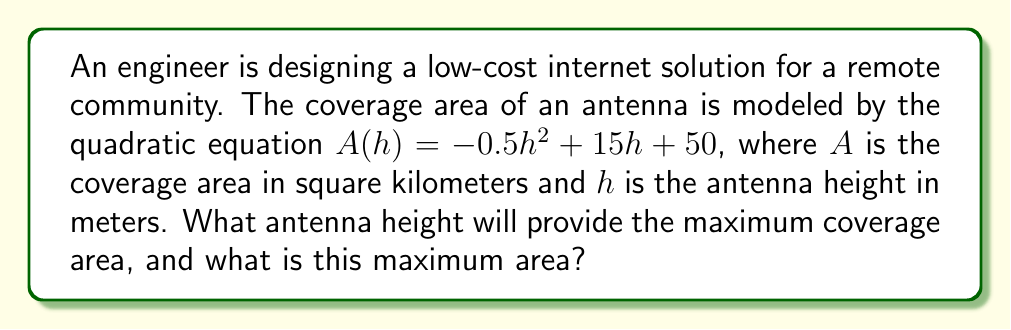Could you help me with this problem? To solve this problem, we'll follow these steps:

1) The coverage area is given by a quadratic function $A(h) = -0.5h^2 + 15h + 50$. The maximum of a quadratic function occurs at the vertex of the parabola.

2) For a quadratic function in the form $f(x) = ax^2 + bx + c$, the h-coordinate of the vertex is given by $h = -\frac{b}{2a}$.

3) In our case, $a = -0.5$, $b = 15$, and $c = 50$. Let's substitute these into the formula:

   $h = -\frac{15}{2(-0.5)} = -\frac{15}{-1} = 15$

4) Therefore, the antenna height that provides maximum coverage is 15 meters.

5) To find the maximum coverage area, we substitute $h = 15$ into the original equation:

   $A(15) = -0.5(15)^2 + 15(15) + 50$
   $= -0.5(225) + 225 + 50$
   $= -112.5 + 225 + 50$
   $= 162.5$

6) Thus, the maximum coverage area is 162.5 square kilometers.
Answer: 15 meters; 162.5 square kilometers 